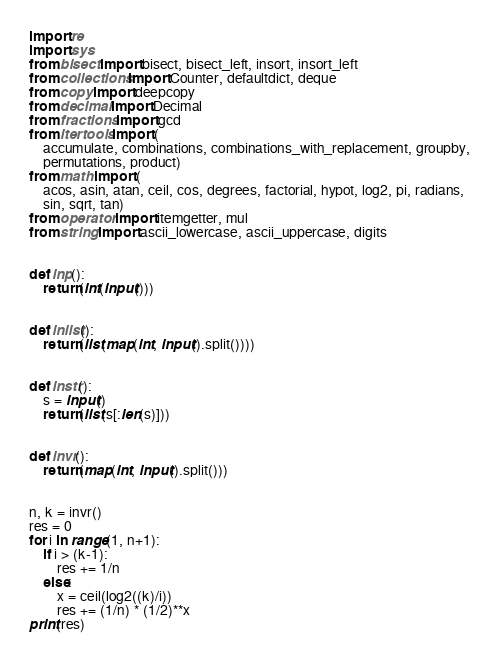<code> <loc_0><loc_0><loc_500><loc_500><_Python_>import re
import sys
from bisect import bisect, bisect_left, insort, insort_left
from collections import Counter, defaultdict, deque
from copy import deepcopy
from decimal import Decimal
from fractions import gcd
from itertools import (
    accumulate, combinations, combinations_with_replacement, groupby,
    permutations, product)
from math import (
    acos, asin, atan, ceil, cos, degrees, factorial, hypot, log2, pi, radians,
    sin, sqrt, tan)
from operator import itemgetter, mul
from string import ascii_lowercase, ascii_uppercase, digits


def inp():
    return(int(input()))


def inlist():
    return(list(map(int, input().split())))


def instr():
    s = input()
    return(list(s[:len(s)]))


def invr():
    return(map(int, input().split()))


n, k = invr()
res = 0
for i in range(1, n+1):
    if i > (k-1):
        res += 1/n
    else:
        x = ceil(log2((k)/i))
        res += (1/n) * (1/2)**x
print(res)
</code> 